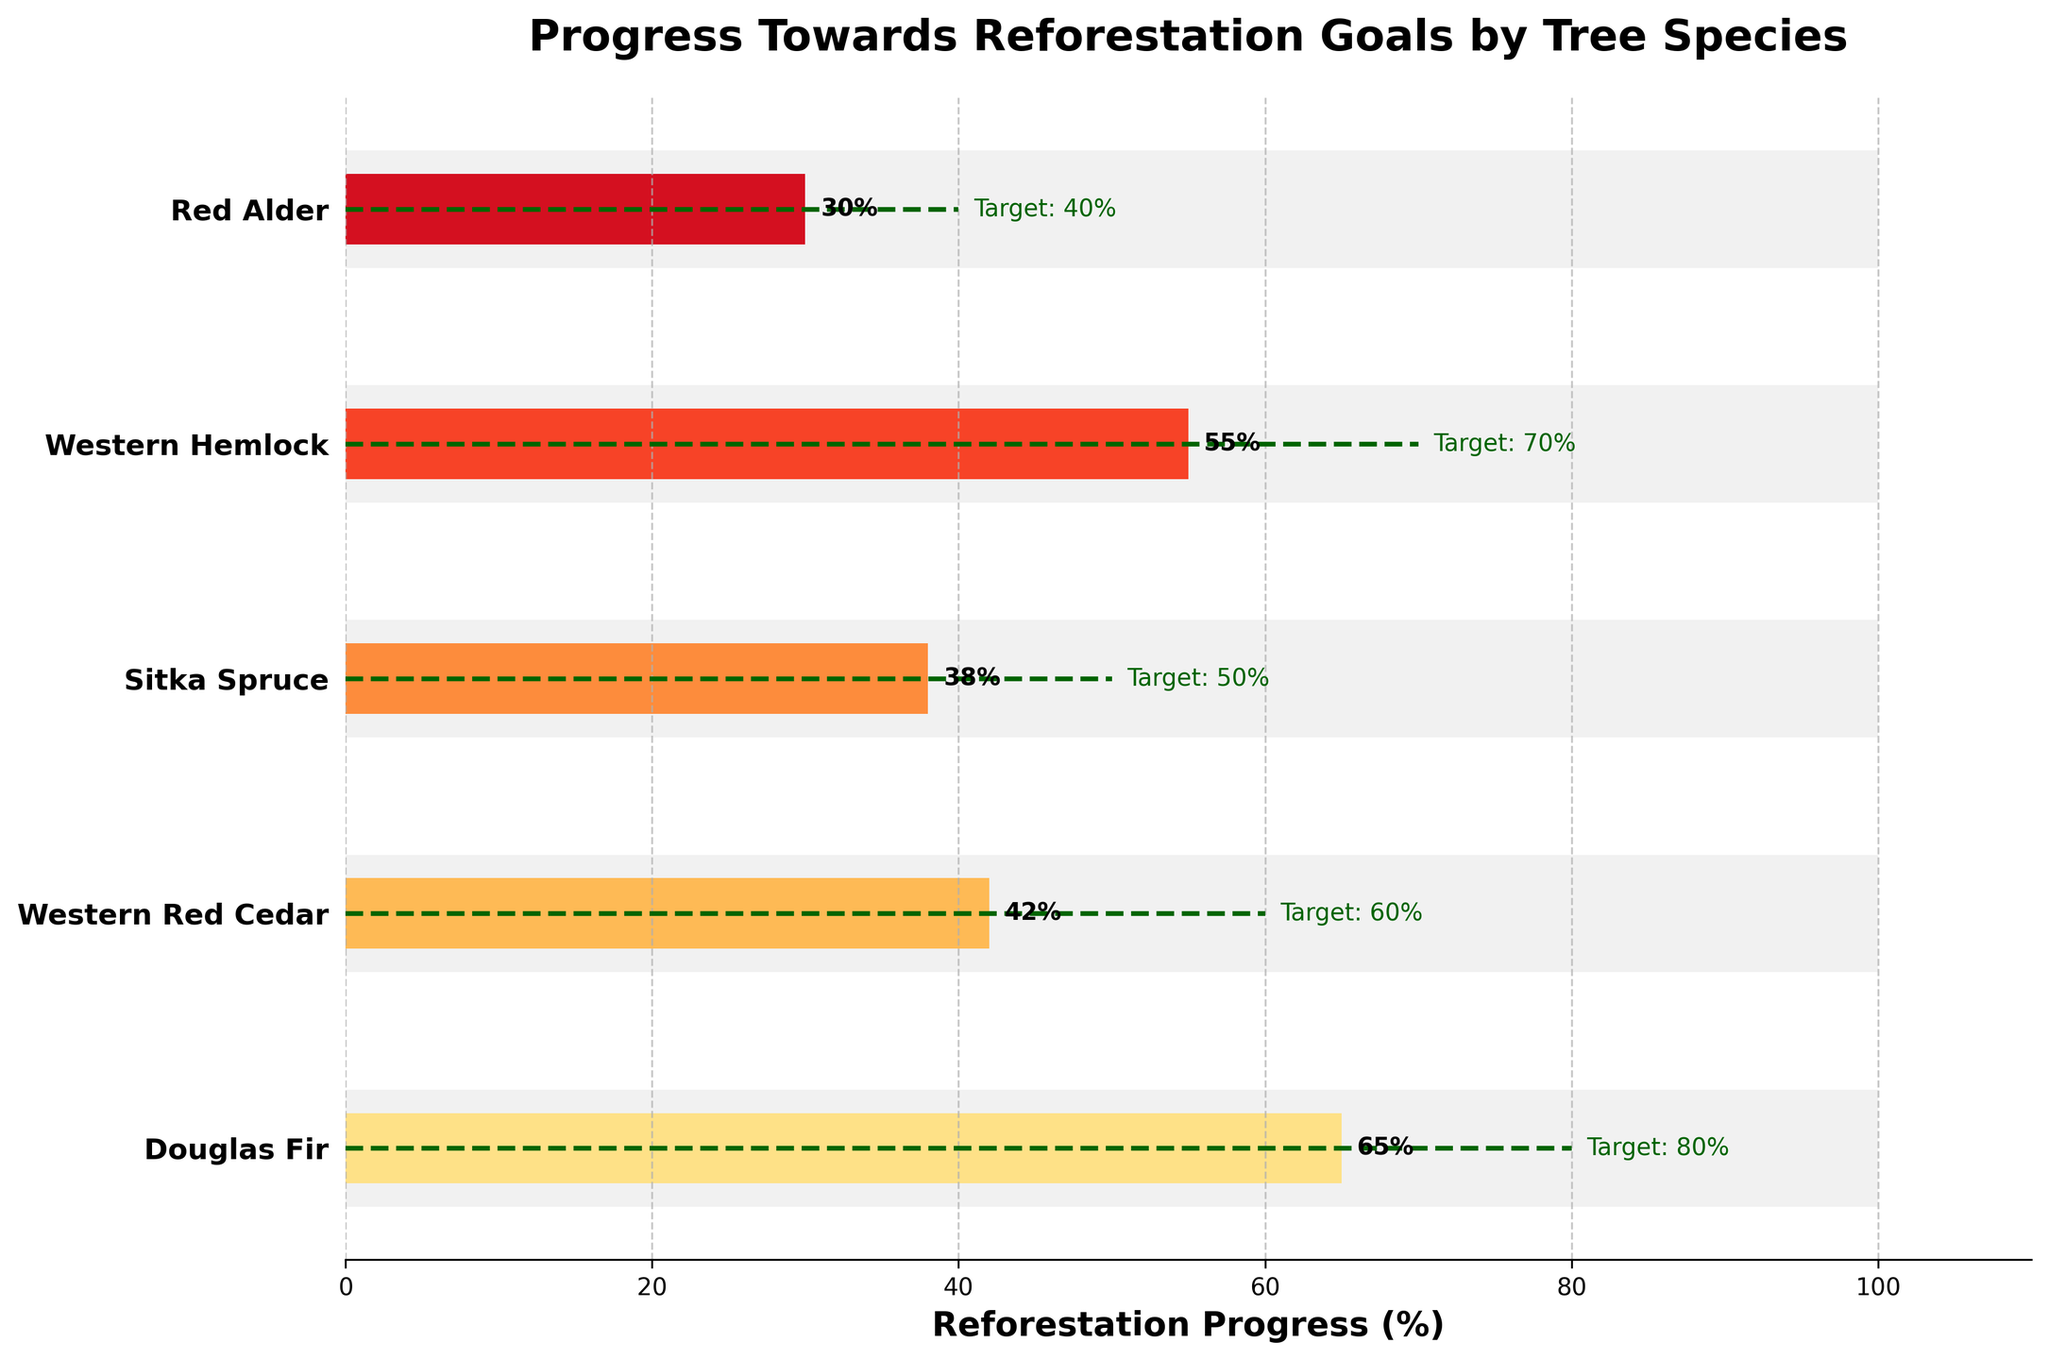What is the title of the figure? The title of the figure is displayed at the top and reads "Progress Towards Reforestation Goals by Tree Species."
Answer: Progress Towards Reforestation Goals by Tree Species How many tree species are shown in the figure? By counting the unique labels on the y-axis, we see that there are five tree species displayed in the figure.
Answer: Five What color is used for the background bars representing the maximum values? The background bars, representing the maximum values, are light grey.
Answer: Light grey Which species has made the most actual progress towards its reforestation goal? By comparing the actual values represented by the bars, we see that "Douglas Fir" has made the most progress with 65%.
Answer: Douglas Fir What is the target reforestation percentage for Western Red Cedar? The target line for Western Red Cedar, indicated by the horizontal dashed line, is positioned at 60%.
Answer: 60% How much progress has the Red Alder species made towards its target percentage? The actual progress for Red Alder is labeled directly at the end of its bar, which shows 30%.
Answer: 30% Which species has the smallest difference between its actual progress and its target? The species with the smallest difference between its actual and target progress is determined by calculating the differences: Douglas Fir (15), Western Red Cedar (18), Sitka Spruce (12), Western Hemlock (15), and Red Alder (10). Sitka Spruce has the smallest difference.
Answer: Sitka Spruce How many tree species have targets set at or above 70%? By examining the target positions, Western Hemlock has a target of 70%, and none of the others have a higher target. So, only one species has a target at or above 70%.
Answer: One Which tree species has the least actual progress towards reforestation goals? The species with the lowest actual value on the bars is "Red Alder" with 30%.
Answer: Red Alder What is the average target percentage for all tree species shown? Adding the targets: 80 (Douglas Fir) + 60 (Western Red Cedar) + 50 (Sitka Spruce) + 70 (Western Hemlock) + 40 (Red Alder) = 300. Then, dividing by the number of species (5), we get 300 / 5 = 60%.
Answer: 60% 